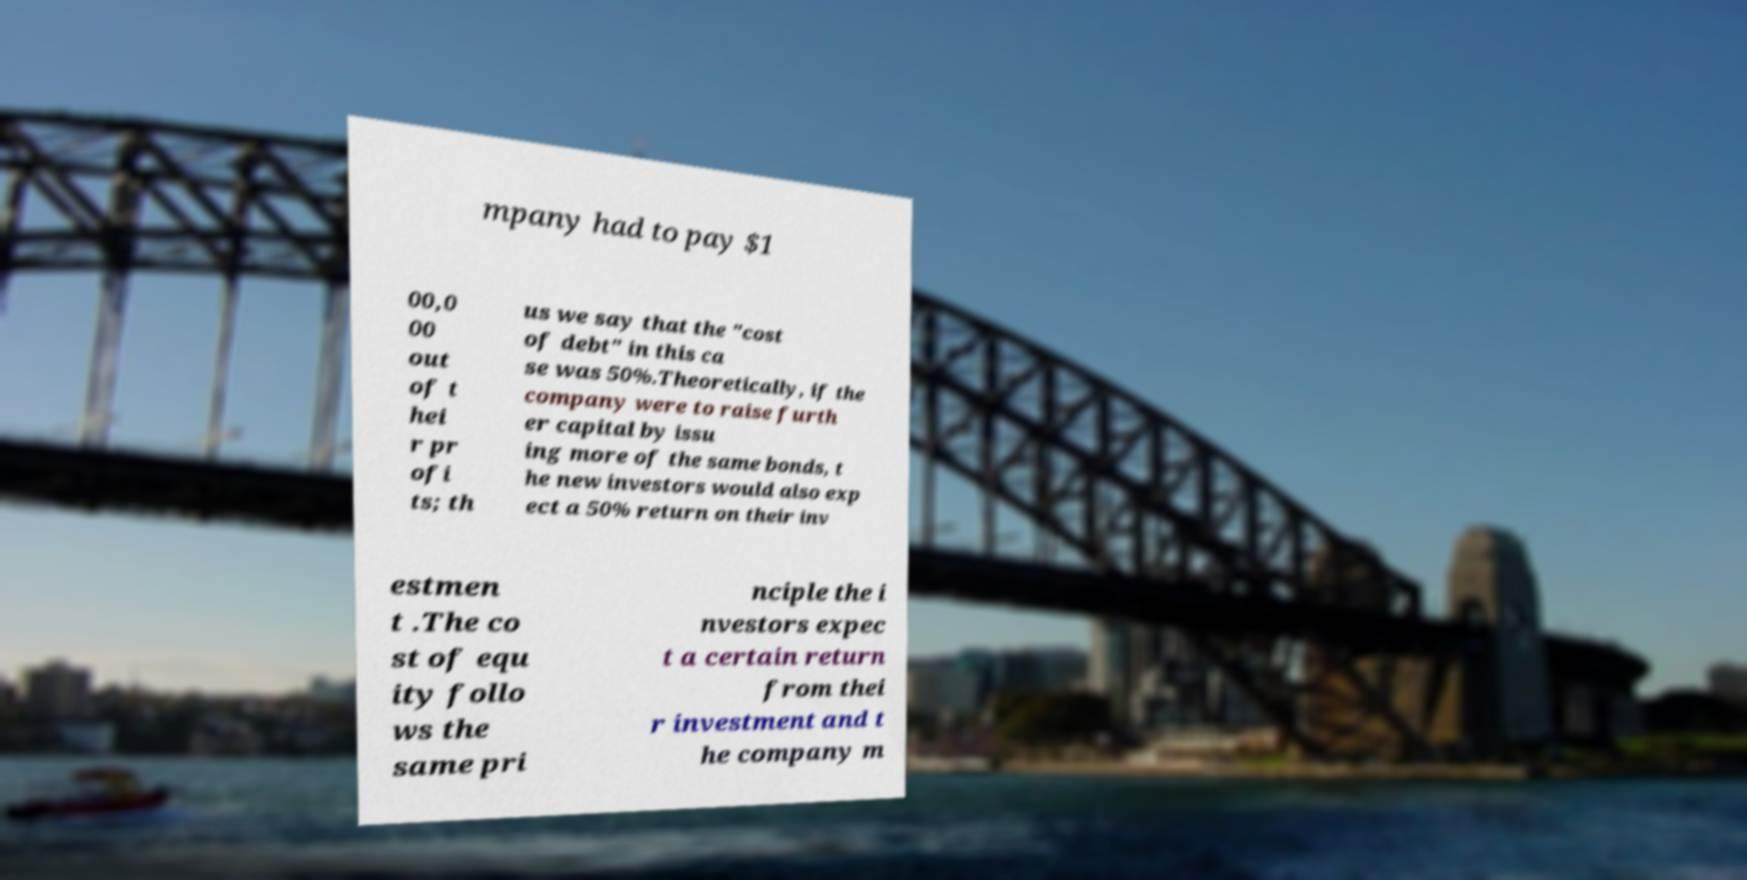For documentation purposes, I need the text within this image transcribed. Could you provide that? mpany had to pay $1 00,0 00 out of t hei r pr ofi ts; th us we say that the "cost of debt" in this ca se was 50%.Theoretically, if the company were to raise furth er capital by issu ing more of the same bonds, t he new investors would also exp ect a 50% return on their inv estmen t .The co st of equ ity follo ws the same pri nciple the i nvestors expec t a certain return from thei r investment and t he company m 